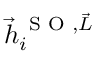<formula> <loc_0><loc_0><loc_500><loc_500>\vec { h } _ { i } ^ { \, S O , \vec { L } }</formula> 